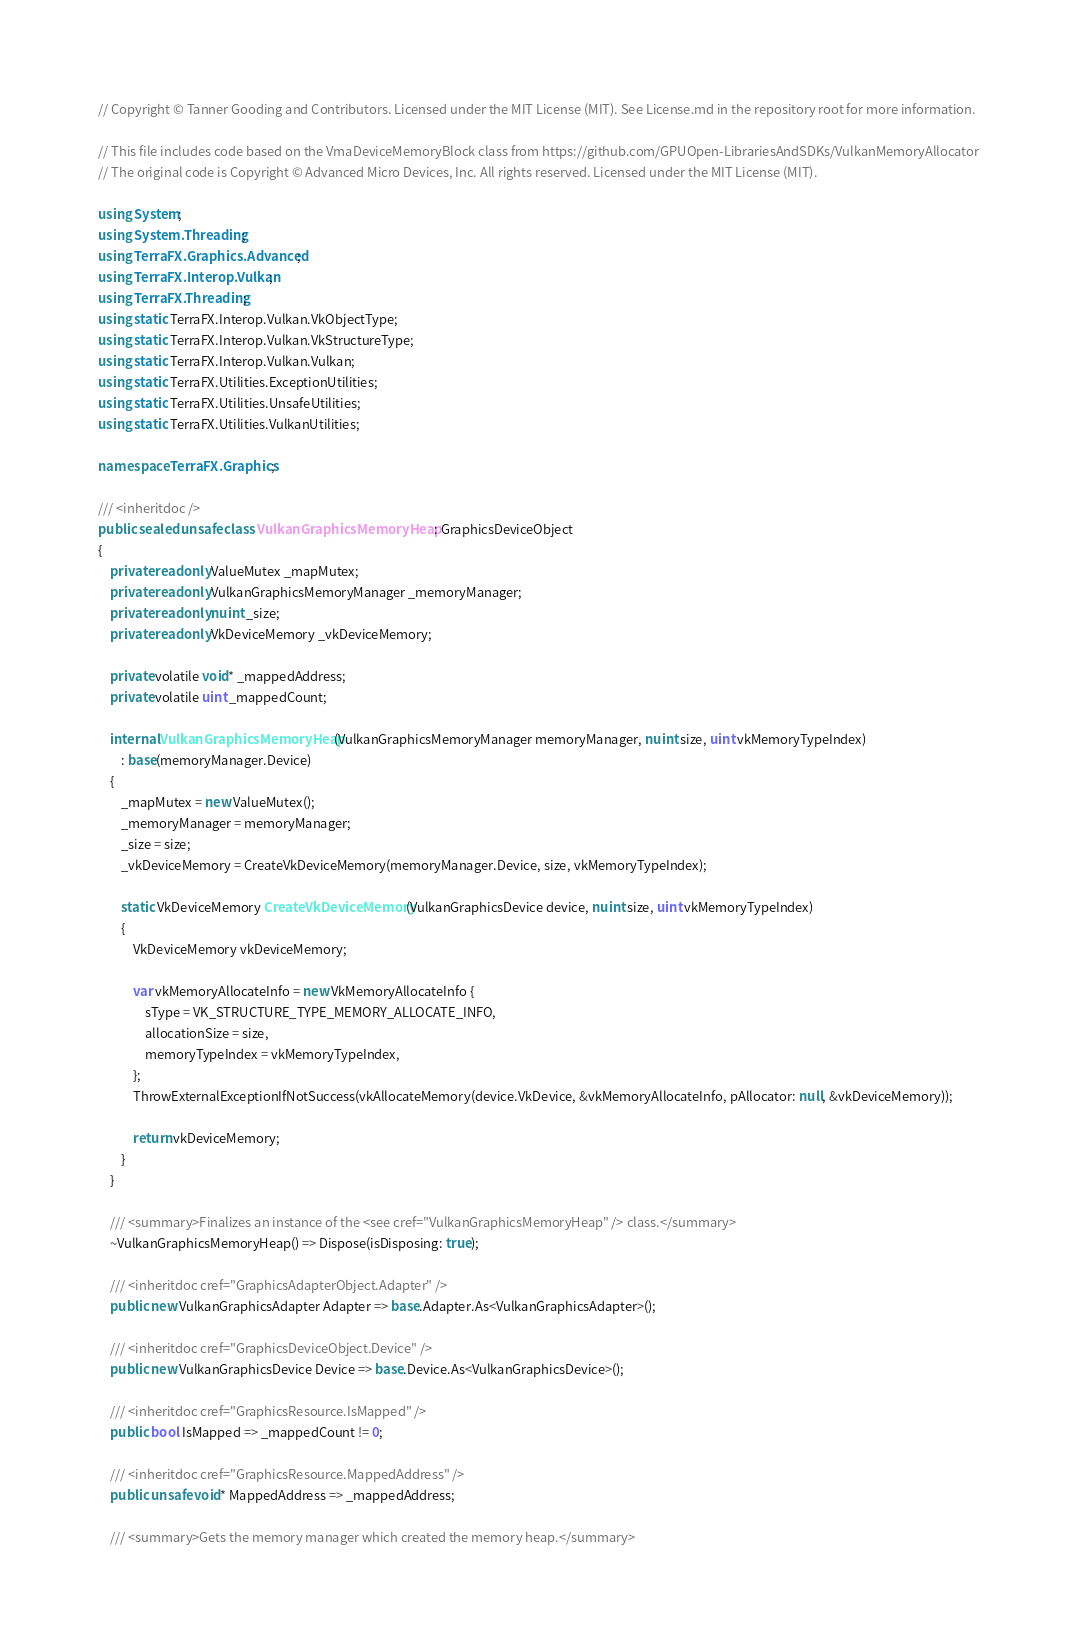<code> <loc_0><loc_0><loc_500><loc_500><_C#_>// Copyright © Tanner Gooding and Contributors. Licensed under the MIT License (MIT). See License.md in the repository root for more information.

// This file includes code based on the VmaDeviceMemoryBlock class from https://github.com/GPUOpen-LibrariesAndSDKs/VulkanMemoryAllocator
// The original code is Copyright © Advanced Micro Devices, Inc. All rights reserved. Licensed under the MIT License (MIT).

using System;
using System.Threading;
using TerraFX.Graphics.Advanced;
using TerraFX.Interop.Vulkan;
using TerraFX.Threading;
using static TerraFX.Interop.Vulkan.VkObjectType;
using static TerraFX.Interop.Vulkan.VkStructureType;
using static TerraFX.Interop.Vulkan.Vulkan;
using static TerraFX.Utilities.ExceptionUtilities;
using static TerraFX.Utilities.UnsafeUtilities;
using static TerraFX.Utilities.VulkanUtilities;

namespace TerraFX.Graphics;

/// <inheritdoc />
public sealed unsafe class VulkanGraphicsMemoryHeap : GraphicsDeviceObject
{
    private readonly ValueMutex _mapMutex;
    private readonly VulkanGraphicsMemoryManager _memoryManager;
    private readonly nuint _size;
    private readonly VkDeviceMemory _vkDeviceMemory;

    private volatile void* _mappedAddress;
    private volatile uint _mappedCount;

    internal VulkanGraphicsMemoryHeap(VulkanGraphicsMemoryManager memoryManager, nuint size, uint vkMemoryTypeIndex)
        : base(memoryManager.Device)
    {
        _mapMutex = new ValueMutex();
        _memoryManager = memoryManager;
        _size = size;
        _vkDeviceMemory = CreateVkDeviceMemory(memoryManager.Device, size, vkMemoryTypeIndex);

        static VkDeviceMemory CreateVkDeviceMemory(VulkanGraphicsDevice device, nuint size, uint vkMemoryTypeIndex)
        {
            VkDeviceMemory vkDeviceMemory;

            var vkMemoryAllocateInfo = new VkMemoryAllocateInfo {
                sType = VK_STRUCTURE_TYPE_MEMORY_ALLOCATE_INFO,
                allocationSize = size,
                memoryTypeIndex = vkMemoryTypeIndex,
            };
            ThrowExternalExceptionIfNotSuccess(vkAllocateMemory(device.VkDevice, &vkMemoryAllocateInfo, pAllocator: null, &vkDeviceMemory));

            return vkDeviceMemory;
        }
    }

    /// <summary>Finalizes an instance of the <see cref="VulkanGraphicsMemoryHeap" /> class.</summary>
    ~VulkanGraphicsMemoryHeap() => Dispose(isDisposing: true);

    /// <inheritdoc cref="GraphicsAdapterObject.Adapter" />
    public new VulkanGraphicsAdapter Adapter => base.Adapter.As<VulkanGraphicsAdapter>();

    /// <inheritdoc cref="GraphicsDeviceObject.Device" />
    public new VulkanGraphicsDevice Device => base.Device.As<VulkanGraphicsDevice>();

    /// <inheritdoc cref="GraphicsResource.IsMapped" />
    public bool IsMapped => _mappedCount != 0;

    /// <inheritdoc cref="GraphicsResource.MappedAddress" />
    public unsafe void* MappedAddress => _mappedAddress;

    /// <summary>Gets the memory manager which created the memory heap.</summary></code> 